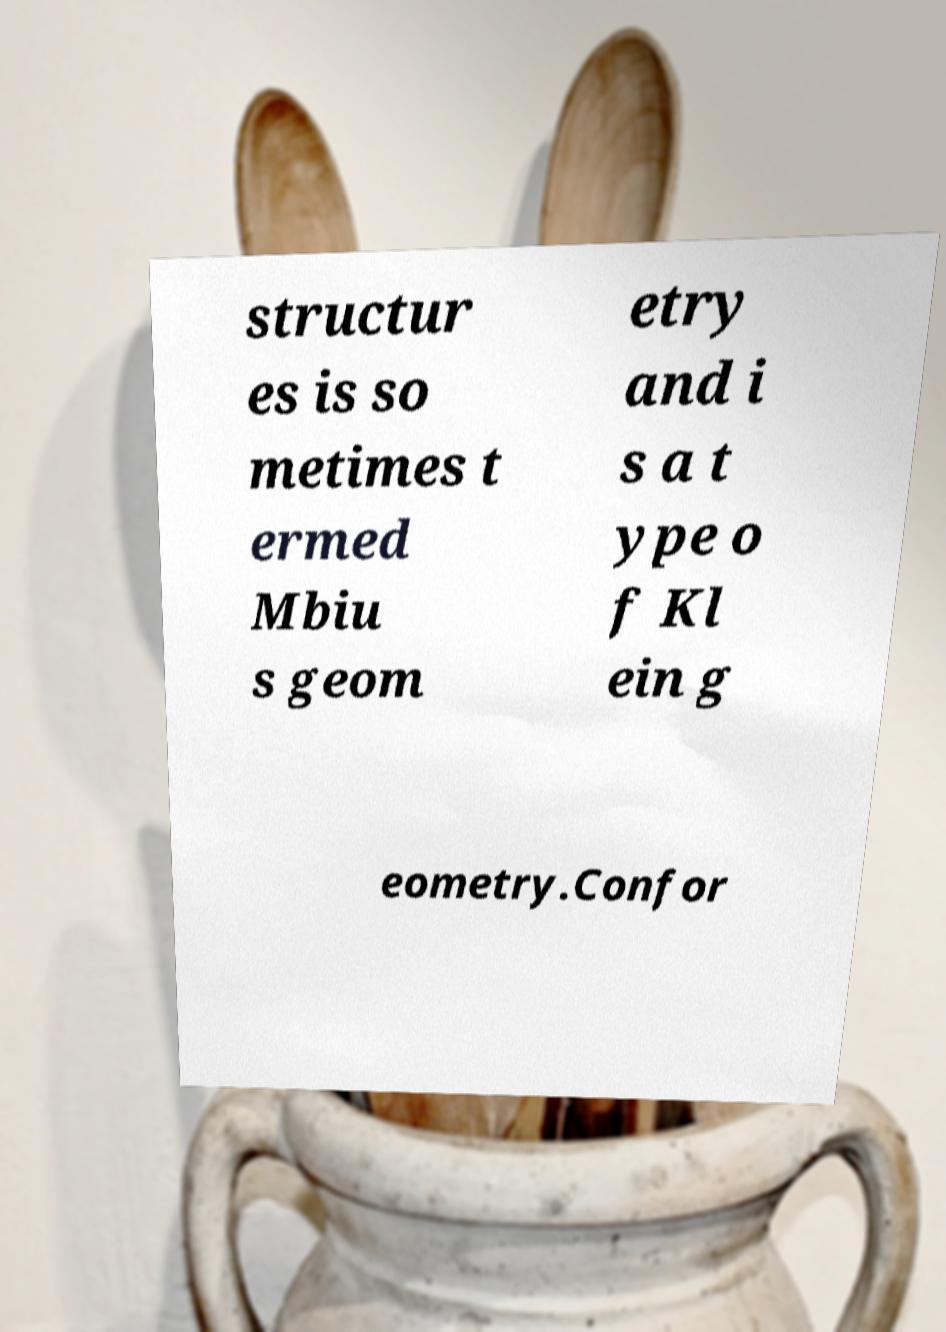I need the written content from this picture converted into text. Can you do that? structur es is so metimes t ermed Mbiu s geom etry and i s a t ype o f Kl ein g eometry.Confor 